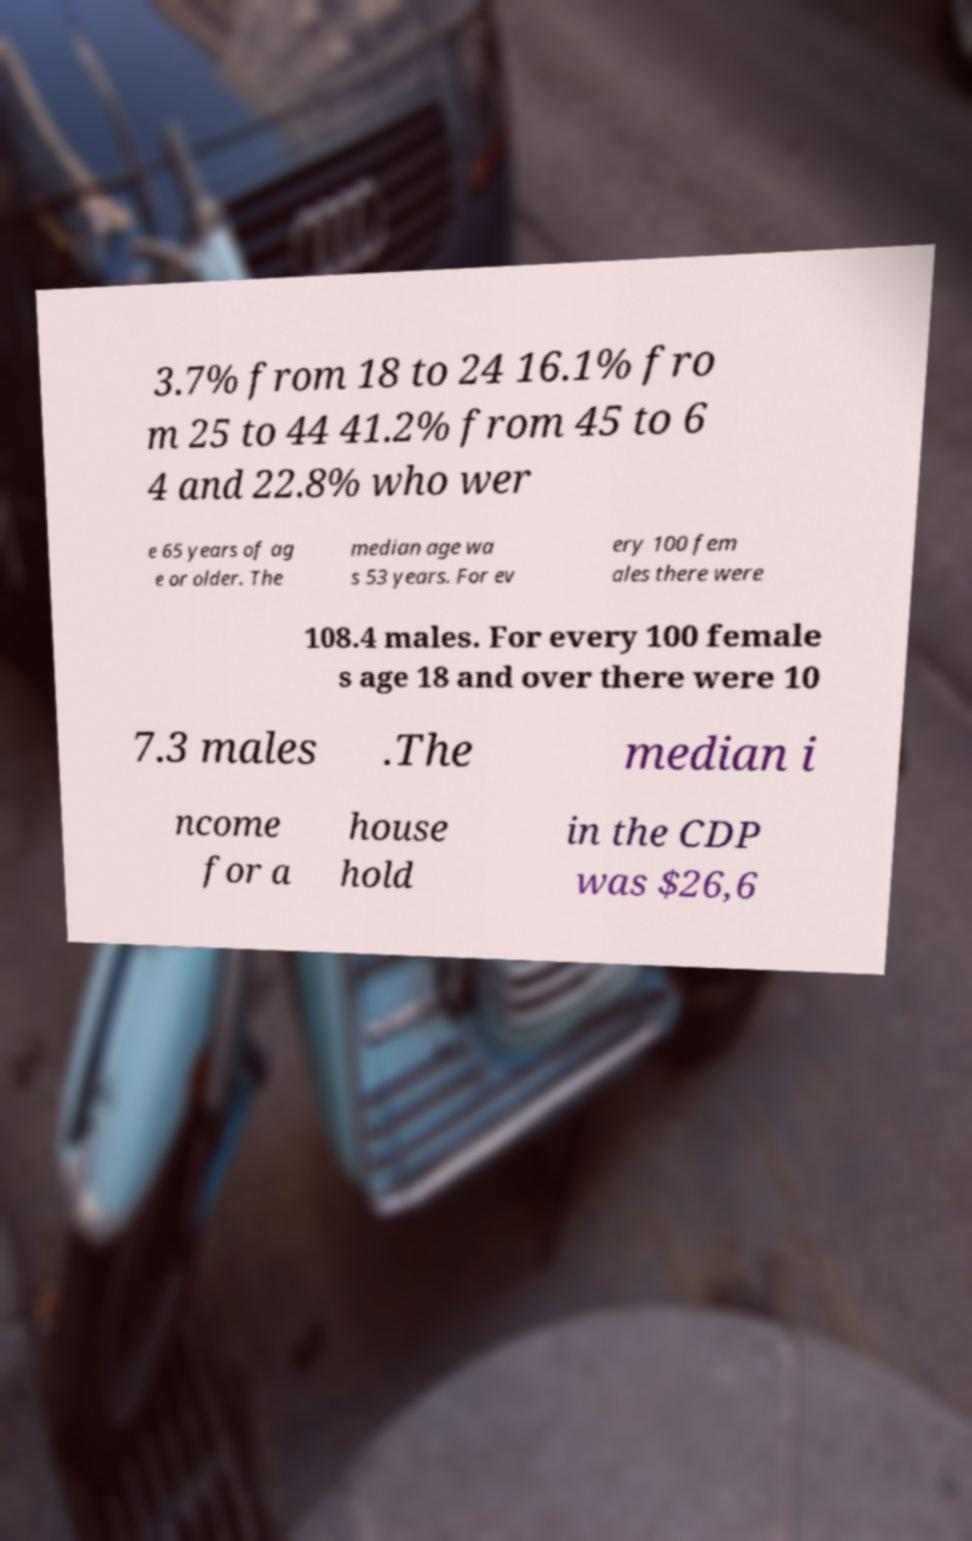For documentation purposes, I need the text within this image transcribed. Could you provide that? 3.7% from 18 to 24 16.1% fro m 25 to 44 41.2% from 45 to 6 4 and 22.8% who wer e 65 years of ag e or older. The median age wa s 53 years. For ev ery 100 fem ales there were 108.4 males. For every 100 female s age 18 and over there were 10 7.3 males .The median i ncome for a house hold in the CDP was $26,6 